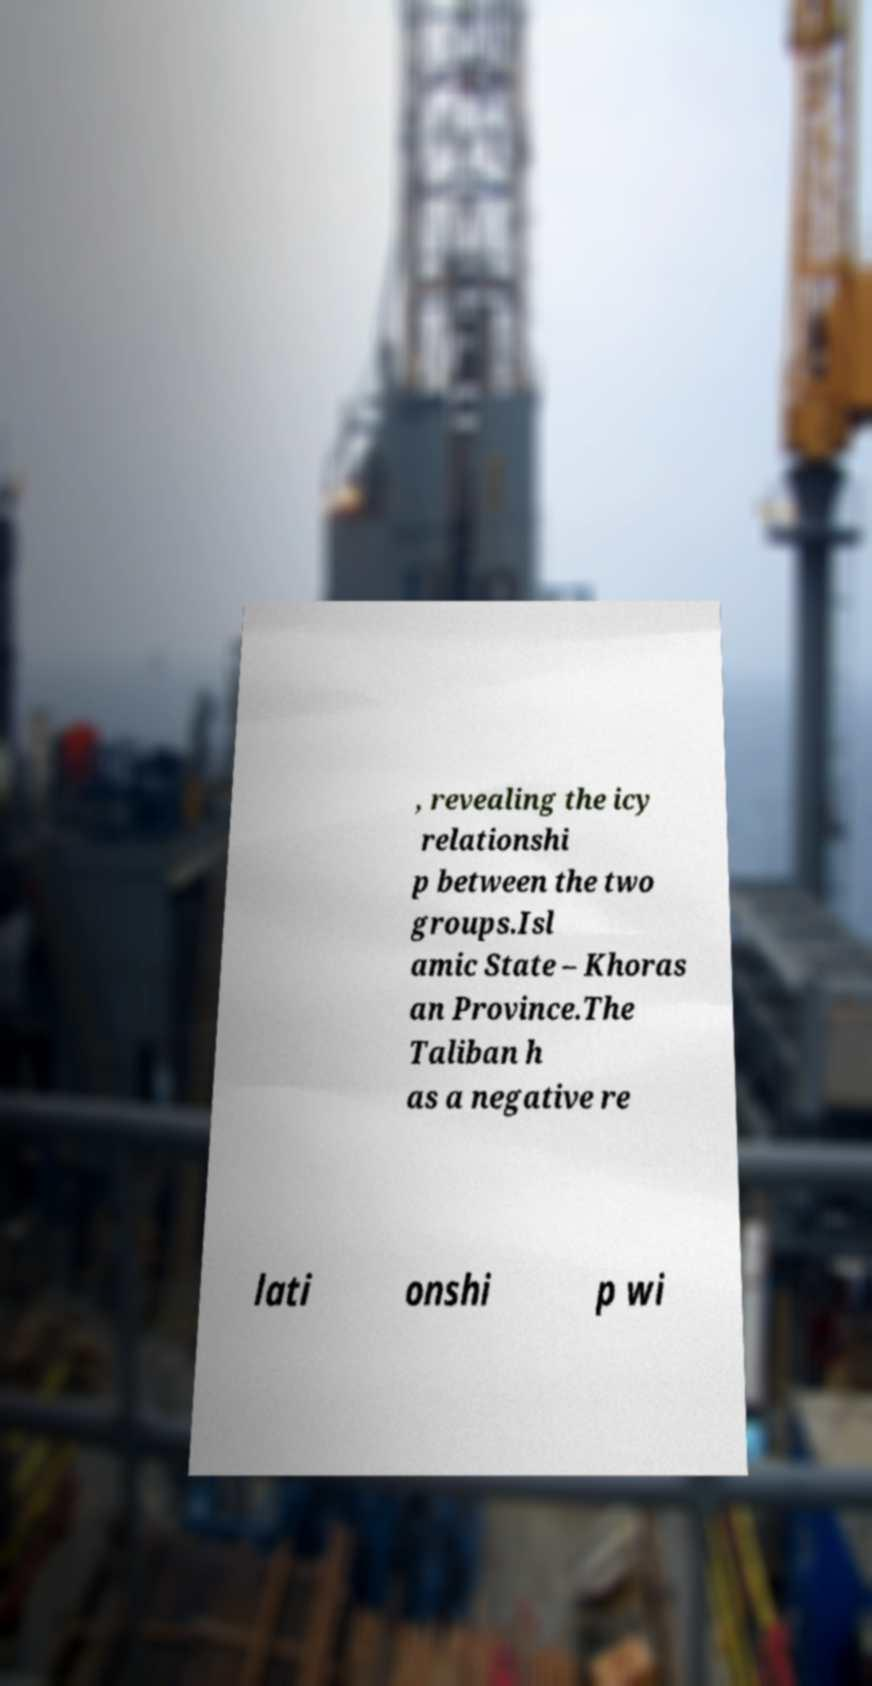Could you assist in decoding the text presented in this image and type it out clearly? , revealing the icy relationshi p between the two groups.Isl amic State – Khoras an Province.The Taliban h as a negative re lati onshi p wi 